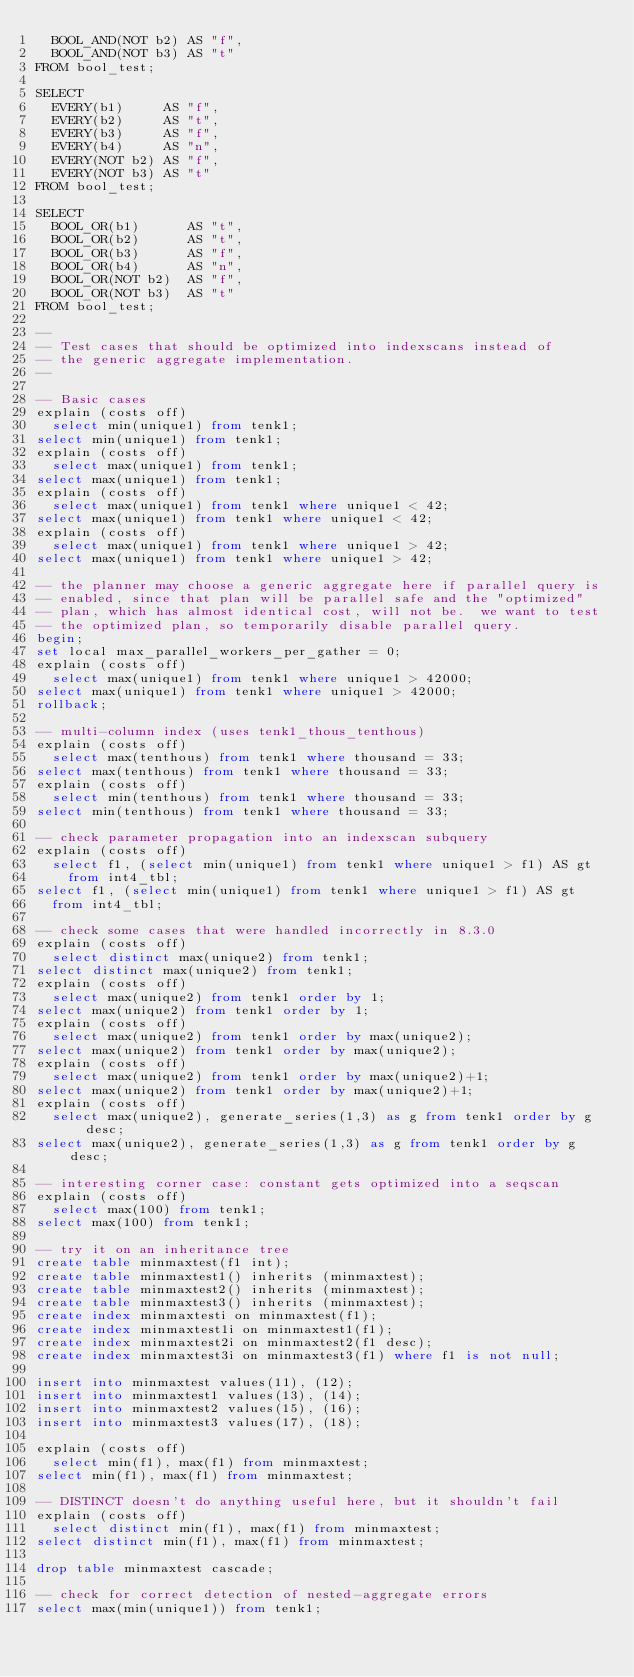<code> <loc_0><loc_0><loc_500><loc_500><_SQL_>  BOOL_AND(NOT b2) AS "f",
  BOOL_AND(NOT b3) AS "t"
FROM bool_test;

SELECT
  EVERY(b1)     AS "f",
  EVERY(b2)     AS "t",
  EVERY(b3)     AS "f",
  EVERY(b4)     AS "n",
  EVERY(NOT b2) AS "f",
  EVERY(NOT b3) AS "t"
FROM bool_test;

SELECT
  BOOL_OR(b1)      AS "t",
  BOOL_OR(b2)      AS "t",
  BOOL_OR(b3)      AS "f",
  BOOL_OR(b4)      AS "n",
  BOOL_OR(NOT b2)  AS "f",
  BOOL_OR(NOT b3)  AS "t"
FROM bool_test;

--
-- Test cases that should be optimized into indexscans instead of
-- the generic aggregate implementation.
--

-- Basic cases
explain (costs off)
  select min(unique1) from tenk1;
select min(unique1) from tenk1;
explain (costs off)
  select max(unique1) from tenk1;
select max(unique1) from tenk1;
explain (costs off)
  select max(unique1) from tenk1 where unique1 < 42;
select max(unique1) from tenk1 where unique1 < 42;
explain (costs off)
  select max(unique1) from tenk1 where unique1 > 42;
select max(unique1) from tenk1 where unique1 > 42;

-- the planner may choose a generic aggregate here if parallel query is
-- enabled, since that plan will be parallel safe and the "optimized"
-- plan, which has almost identical cost, will not be.  we want to test
-- the optimized plan, so temporarily disable parallel query.
begin;
set local max_parallel_workers_per_gather = 0;
explain (costs off)
  select max(unique1) from tenk1 where unique1 > 42000;
select max(unique1) from tenk1 where unique1 > 42000;
rollback;

-- multi-column index (uses tenk1_thous_tenthous)
explain (costs off)
  select max(tenthous) from tenk1 where thousand = 33;
select max(tenthous) from tenk1 where thousand = 33;
explain (costs off)
  select min(tenthous) from tenk1 where thousand = 33;
select min(tenthous) from tenk1 where thousand = 33;

-- check parameter propagation into an indexscan subquery
explain (costs off)
  select f1, (select min(unique1) from tenk1 where unique1 > f1) AS gt
    from int4_tbl;
select f1, (select min(unique1) from tenk1 where unique1 > f1) AS gt
  from int4_tbl;

-- check some cases that were handled incorrectly in 8.3.0
explain (costs off)
  select distinct max(unique2) from tenk1;
select distinct max(unique2) from tenk1;
explain (costs off)
  select max(unique2) from tenk1 order by 1;
select max(unique2) from tenk1 order by 1;
explain (costs off)
  select max(unique2) from tenk1 order by max(unique2);
select max(unique2) from tenk1 order by max(unique2);
explain (costs off)
  select max(unique2) from tenk1 order by max(unique2)+1;
select max(unique2) from tenk1 order by max(unique2)+1;
explain (costs off)
  select max(unique2), generate_series(1,3) as g from tenk1 order by g desc;
select max(unique2), generate_series(1,3) as g from tenk1 order by g desc;

-- interesting corner case: constant gets optimized into a seqscan
explain (costs off)
  select max(100) from tenk1;
select max(100) from tenk1;

-- try it on an inheritance tree
create table minmaxtest(f1 int);
create table minmaxtest1() inherits (minmaxtest);
create table minmaxtest2() inherits (minmaxtest);
create table minmaxtest3() inherits (minmaxtest);
create index minmaxtesti on minmaxtest(f1);
create index minmaxtest1i on minmaxtest1(f1);
create index minmaxtest2i on minmaxtest2(f1 desc);
create index minmaxtest3i on minmaxtest3(f1) where f1 is not null;

insert into minmaxtest values(11), (12);
insert into minmaxtest1 values(13), (14);
insert into minmaxtest2 values(15), (16);
insert into minmaxtest3 values(17), (18);

explain (costs off)
  select min(f1), max(f1) from minmaxtest;
select min(f1), max(f1) from minmaxtest;

-- DISTINCT doesn't do anything useful here, but it shouldn't fail
explain (costs off)
  select distinct min(f1), max(f1) from minmaxtest;
select distinct min(f1), max(f1) from minmaxtest;

drop table minmaxtest cascade;

-- check for correct detection of nested-aggregate errors
select max(min(unique1)) from tenk1;</code> 